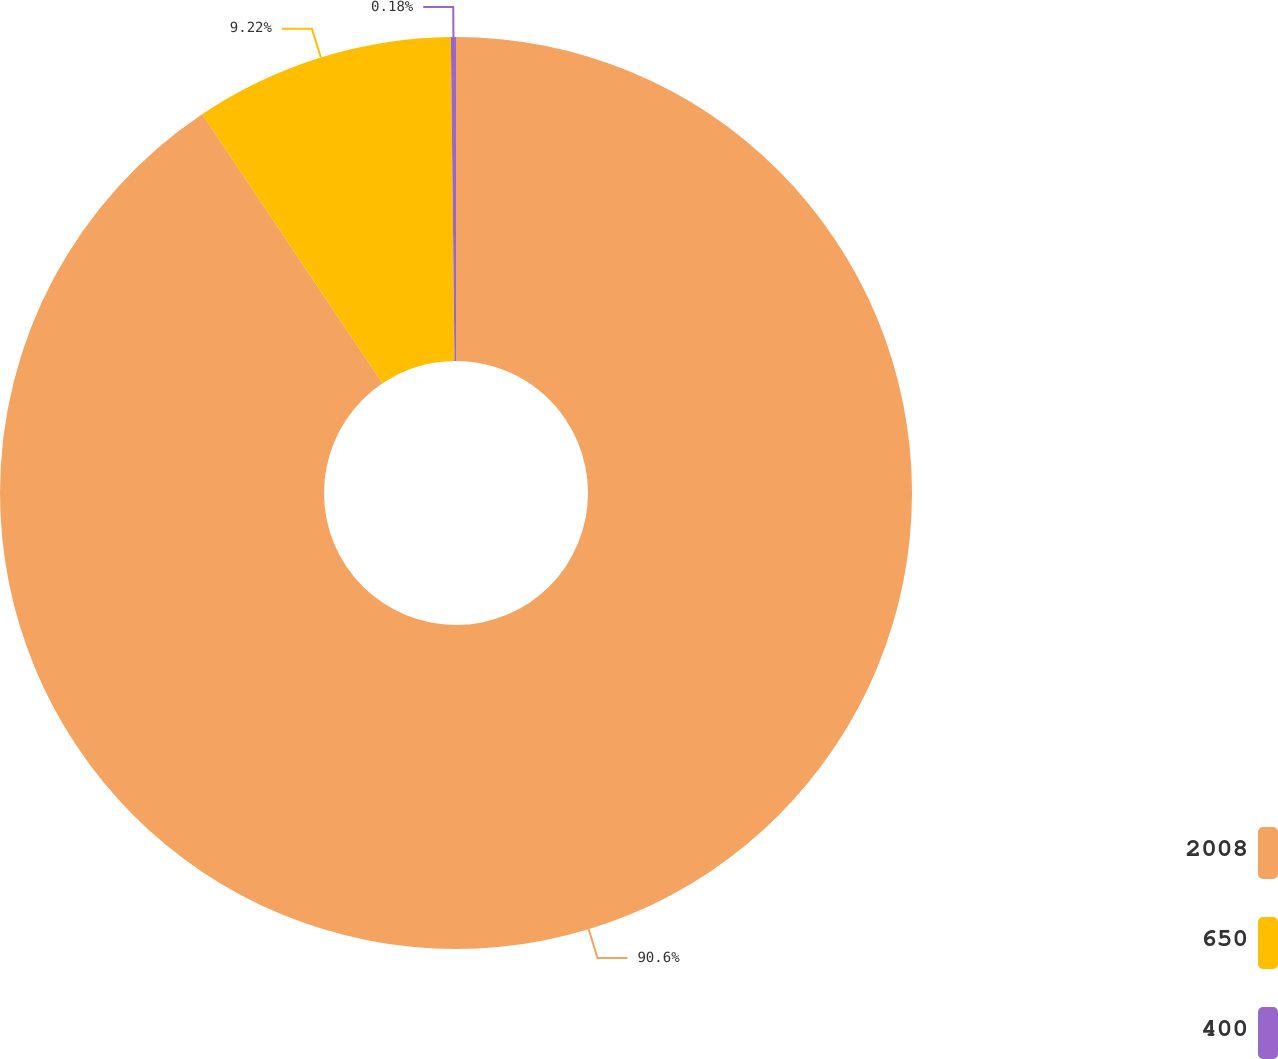Convert chart. <chart><loc_0><loc_0><loc_500><loc_500><pie_chart><fcel>2008<fcel>650<fcel>400<nl><fcel>90.6%<fcel>9.22%<fcel>0.18%<nl></chart> 